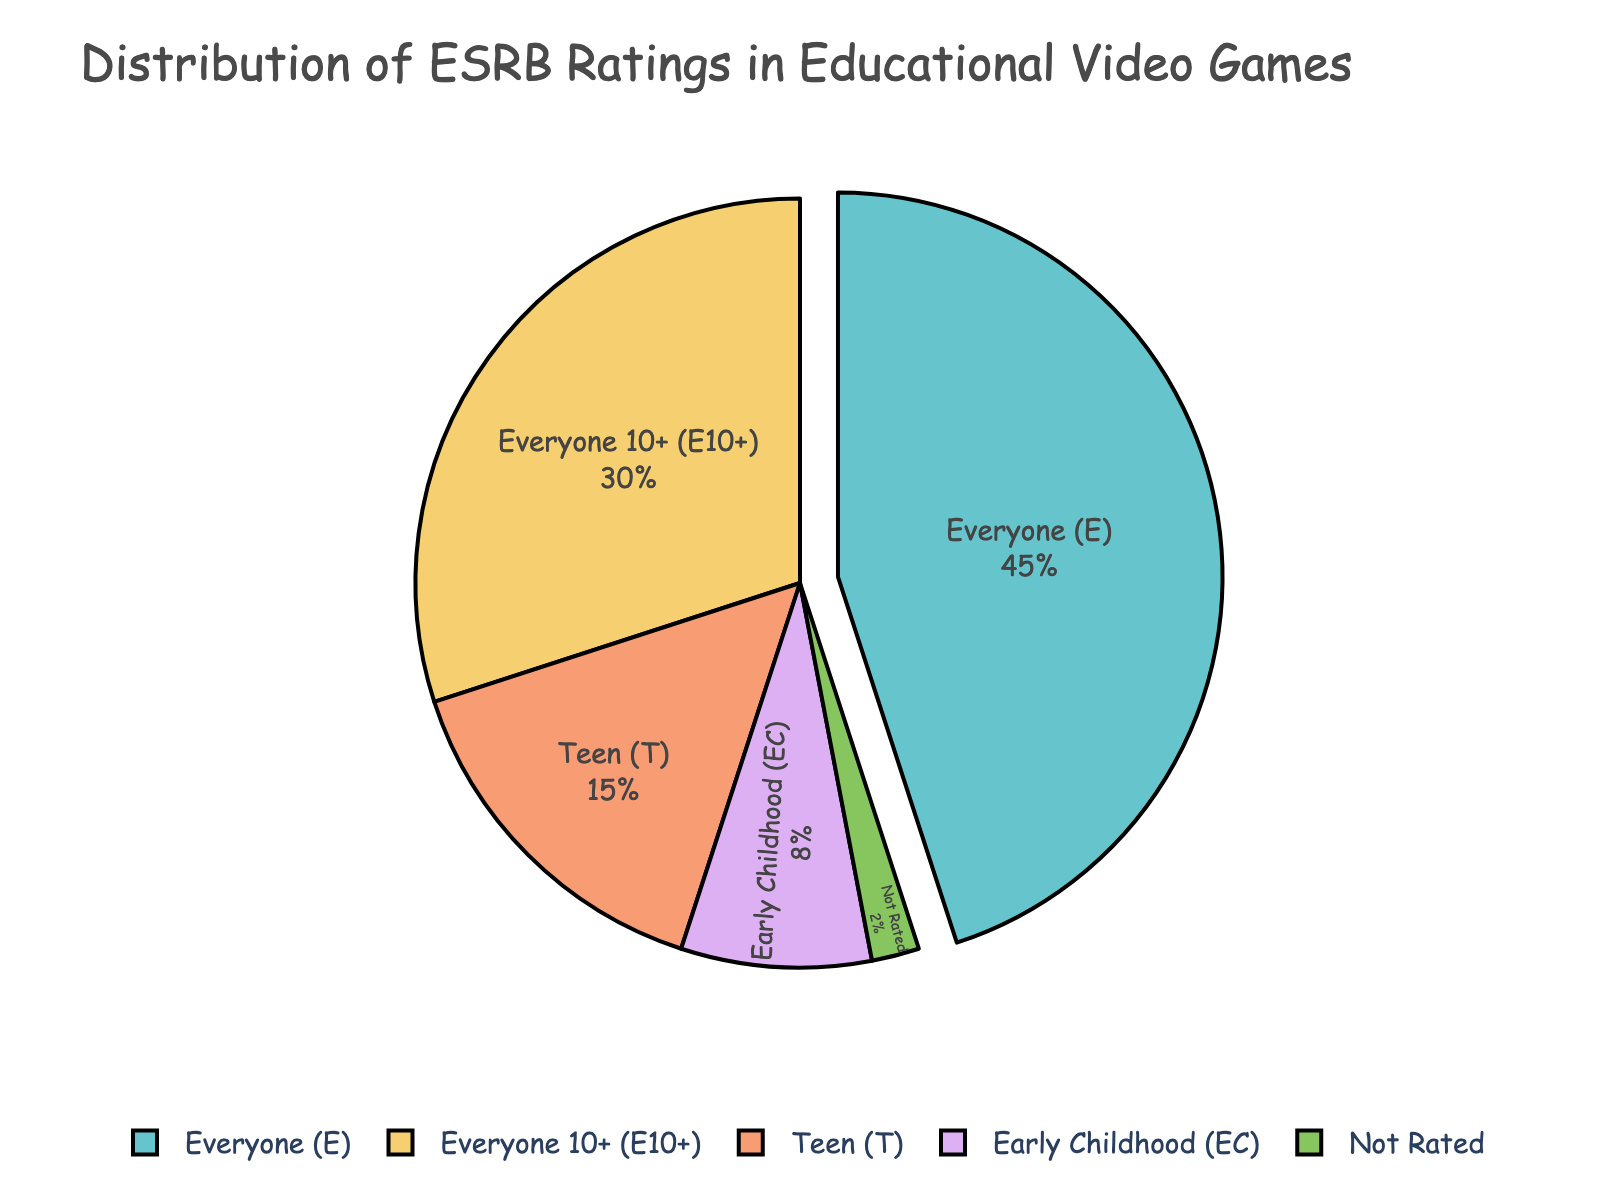What percentage of educational video games are rated Everyone (E)? The pie chart segment for 'Everyone (E)' is given as 45%.
Answer: 45% Which ESRB rating category has the smallest percentage? By examining the pie chart, the 'Not Rated' category has the smallest segment, which is marked as 2%.
Answer: Not Rated How much larger is the percentage of 'Everyone (E)' rated games compared to 'Teen (T)' rated games? The 'Everyone (E)' segment is 45% and the 'Teen (T)' segment is 15%. Subtracting the 'Teen (T)' percentage from 'Everyone (E)' gives 45% - 15% = 30%.
Answer: 30% What is the combined percentage of the 'Everyone (E)' and 'Everyone 10+ (E10+)' categories? The percentage for 'Everyone (E)' is 45% and for 'Everyone 10+ (E10+)' is 30%. Adding these together gives 45% + 30% = 75%.
Answer: 75% Compare and contrast the proportions of 'Early Childhood (EC)' and 'Not Rated' categories. The 'Early Childhood (EC)' is shown as 8%, while 'Not Rated' is 2%. Hence, 'Early Childhood (EC)' is 4 times as much as the 'Not Rated' category.
Answer: 'Early Childhood (EC)' is 4 times 'Not Rated' What fraction of the total percentage is made up by 'Teen (T)' and 'Everyone 10+ (E10+)' categories together? The percentages are 'Teen (T)' = 15% and 'Everyone 10+ (E10+)' = 30%. Adding them gives 15% + 30% = 45%. In fraction form, this is 45/100 or 9/20.
Answer: 9/20 Which category is highlighted or pulled out from the pie chart? The chart visually pulls out the 'Everyone (E)' category from the pie.
Answer: Everyone (E) If we combine all categories except 'Everyone (E)' and compare them as a group, what percentage do they form? The other categories are 30% (E10+), 15% (T), 8% (EC), and 2% (Not Rated). Adding these gives 30% + 15% + 8% + 2% = 55%.
Answer: 55% Identify the categories that have a total percentage under 10%. The 'Early Childhood (EC)' and 'Not Rated' categories are the only ones under 10%, at 8% and 2% respectively.
Answer: Early Childhood (EC) and Not Rated 